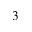Convert formula to latex. <formula><loc_0><loc_0><loc_500><loc_500>^ { 3 }</formula> 